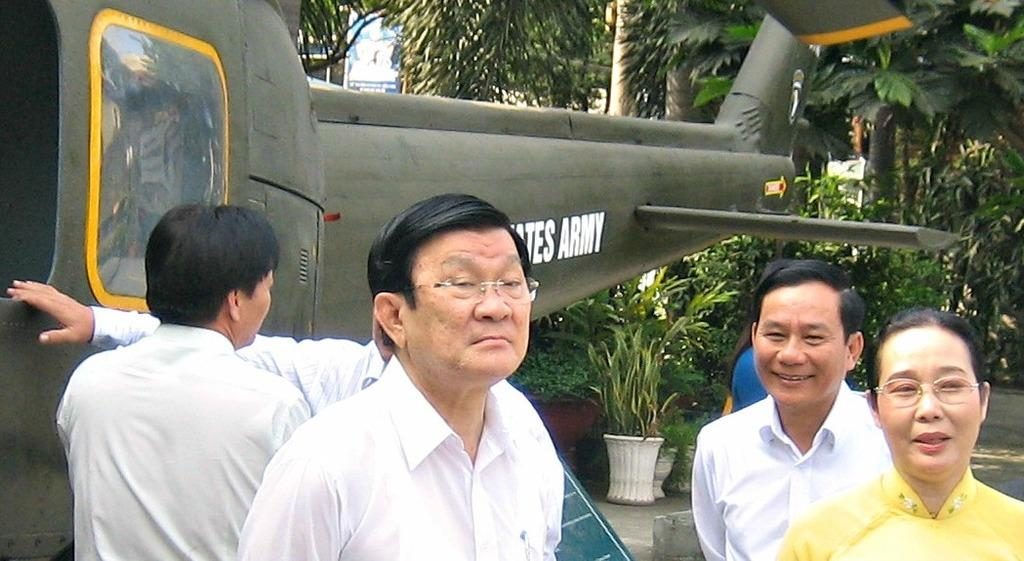<image>
Give a short and clear explanation of the subsequent image. Group of people standing in front of a plane that says "Army" on it. 